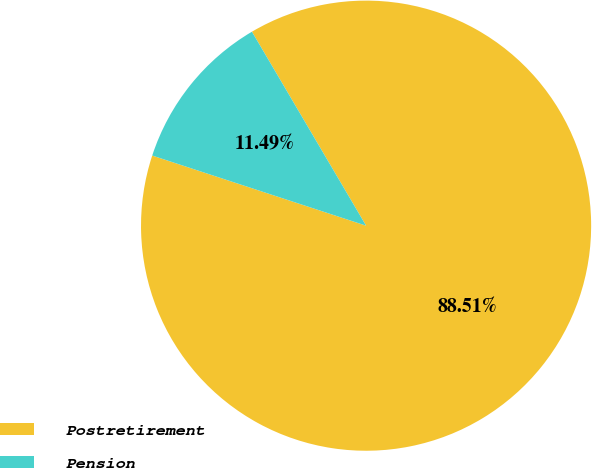<chart> <loc_0><loc_0><loc_500><loc_500><pie_chart><fcel>Postretirement<fcel>Pension<nl><fcel>88.51%<fcel>11.49%<nl></chart> 